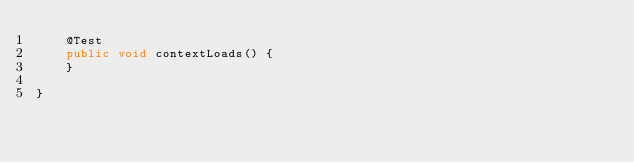Convert code to text. <code><loc_0><loc_0><loc_500><loc_500><_Java_>	@Test
	public void contextLoads() {
	}

}
</code> 